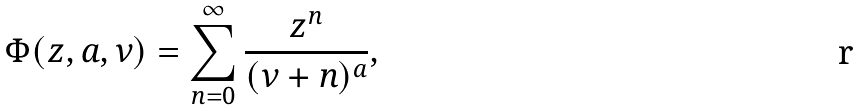Convert formula to latex. <formula><loc_0><loc_0><loc_500><loc_500>\Phi ( z , a , \nu ) = \sum _ { n = 0 } ^ { \infty } \frac { z ^ { n } } { ( \nu + n ) ^ { a } } ,</formula> 